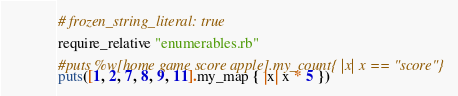Convert code to text. <code><loc_0><loc_0><loc_500><loc_500><_Ruby_># frozen_string_literal: true

require_relative "enumerables.rb"

#puts %w[home game score apple].my_count{ |x| x == "score"}
puts([1, 2, 7, 8, 9, 11].my_map { |x| x * 5 })
</code> 